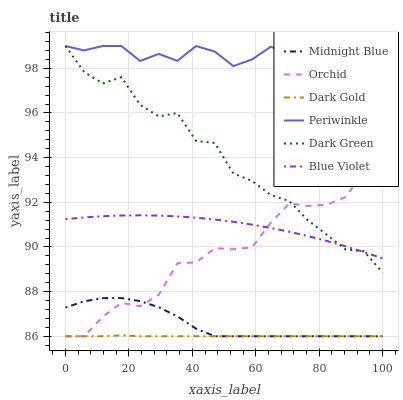Does Dark Gold have the minimum area under the curve?
Answer yes or no. Yes. Does Periwinkle have the maximum area under the curve?
Answer yes or no. Yes. Does Periwinkle have the minimum area under the curve?
Answer yes or no. No. Does Dark Gold have the maximum area under the curve?
Answer yes or no. No. Is Dark Gold the smoothest?
Answer yes or no. Yes. Is Dark Green the roughest?
Answer yes or no. Yes. Is Periwinkle the smoothest?
Answer yes or no. No. Is Periwinkle the roughest?
Answer yes or no. No. Does Midnight Blue have the lowest value?
Answer yes or no. Yes. Does Periwinkle have the lowest value?
Answer yes or no. No. Does Dark Green have the highest value?
Answer yes or no. Yes. Does Dark Gold have the highest value?
Answer yes or no. No. Is Midnight Blue less than Periwinkle?
Answer yes or no. Yes. Is Periwinkle greater than Orchid?
Answer yes or no. Yes. Does Orchid intersect Blue Violet?
Answer yes or no. Yes. Is Orchid less than Blue Violet?
Answer yes or no. No. Is Orchid greater than Blue Violet?
Answer yes or no. No. Does Midnight Blue intersect Periwinkle?
Answer yes or no. No. 